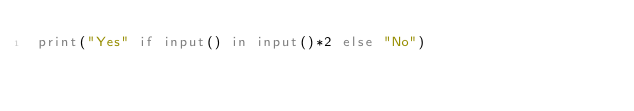Convert code to text. <code><loc_0><loc_0><loc_500><loc_500><_Python_>print("Yes" if input() in input()*2 else "No")</code> 